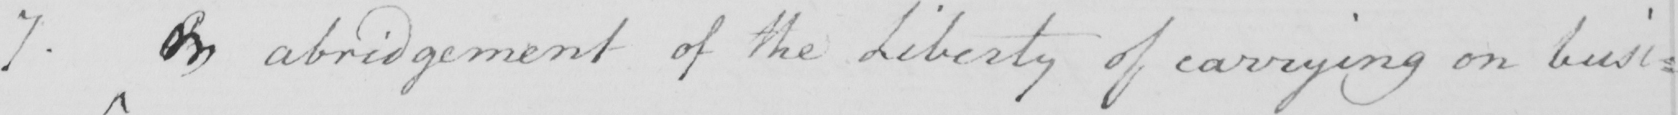Can you tell me what this handwritten text says? 7 . On abridgement of the Liberty of carrying on busi= 